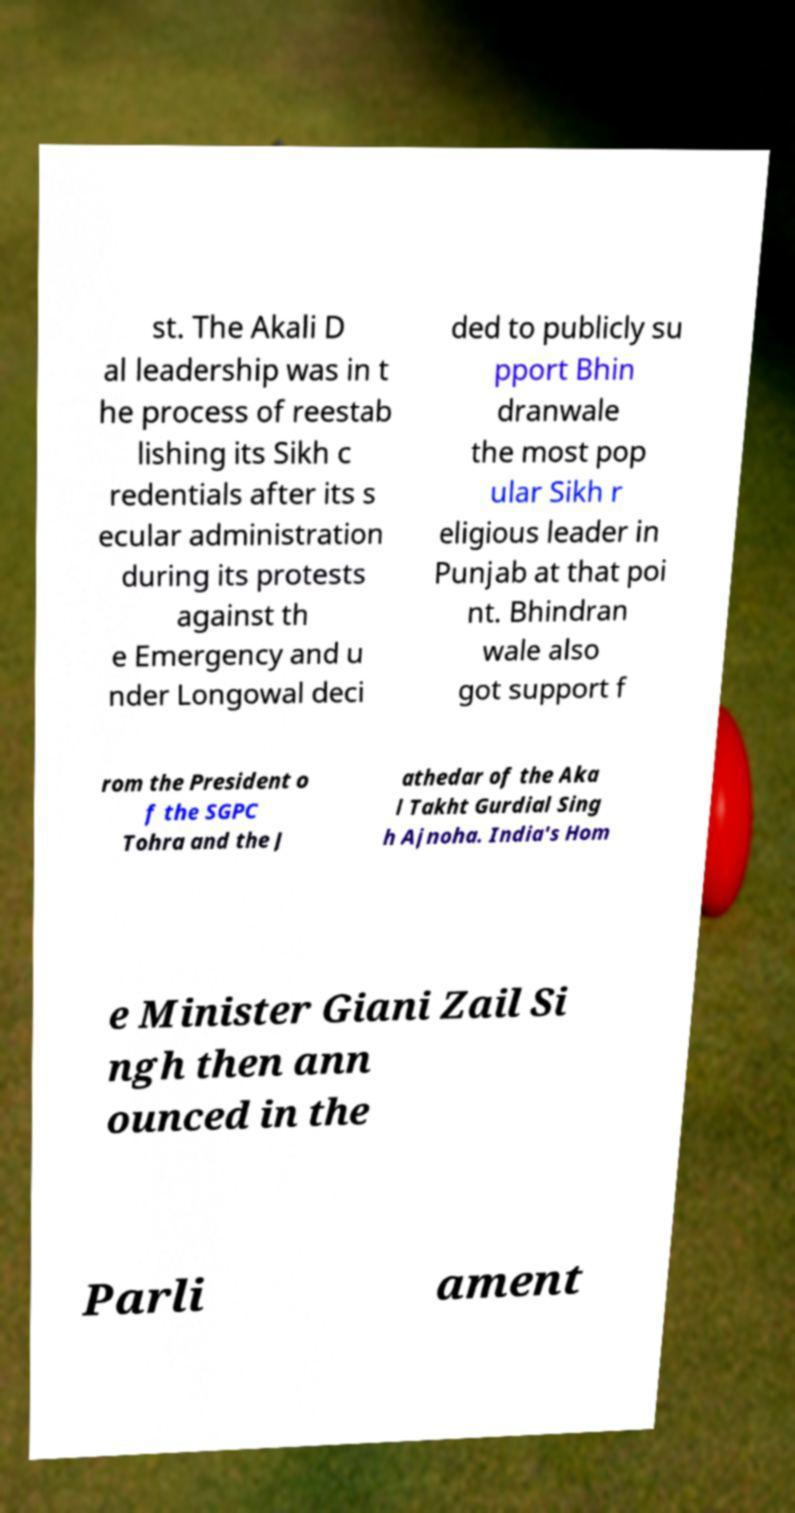Could you assist in decoding the text presented in this image and type it out clearly? st. The Akali D al leadership was in t he process of reestab lishing its Sikh c redentials after its s ecular administration during its protests against th e Emergency and u nder Longowal deci ded to publicly su pport Bhin dranwale the most pop ular Sikh r eligious leader in Punjab at that poi nt. Bhindran wale also got support f rom the President o f the SGPC Tohra and the J athedar of the Aka l Takht Gurdial Sing h Ajnoha. India's Hom e Minister Giani Zail Si ngh then ann ounced in the Parli ament 